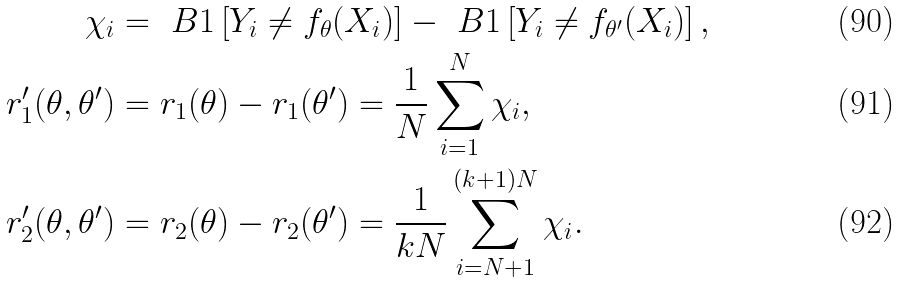Convert formula to latex. <formula><loc_0><loc_0><loc_500><loc_500>\chi _ { i } & = \ B { 1 } \left [ Y _ { i } \neq f _ { \theta } ( X _ { i } ) \right ] - \ B { 1 } \left [ Y _ { i } \neq f _ { \theta ^ { \prime } } ( X _ { i } ) \right ] , \\ r _ { 1 } ^ { \prime } ( \theta , \theta ^ { \prime } ) & = r _ { 1 } ( \theta ) - r _ { 1 } ( \theta ^ { \prime } ) = \frac { 1 } { N } \sum _ { i = 1 } ^ { N } \chi _ { i } , \\ r _ { 2 } ^ { \prime } ( \theta , \theta ^ { \prime } ) & = r _ { 2 } ( \theta ) - r _ { 2 } ( \theta ^ { \prime } ) = \frac { 1 } { k N } \sum _ { i = N + 1 } ^ { ( k + 1 ) N } \chi _ { i } .</formula> 